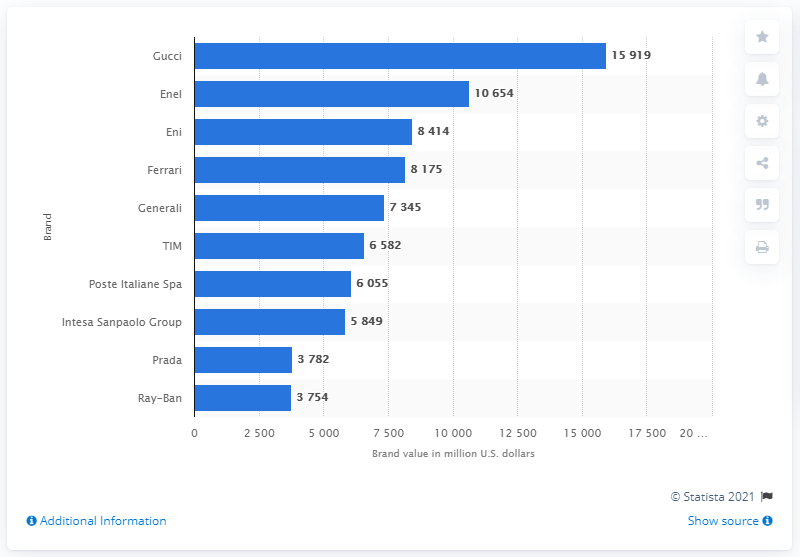Outline some significant characteristics in this image. The most valuable Italian brand in 2020 was Gucci. 